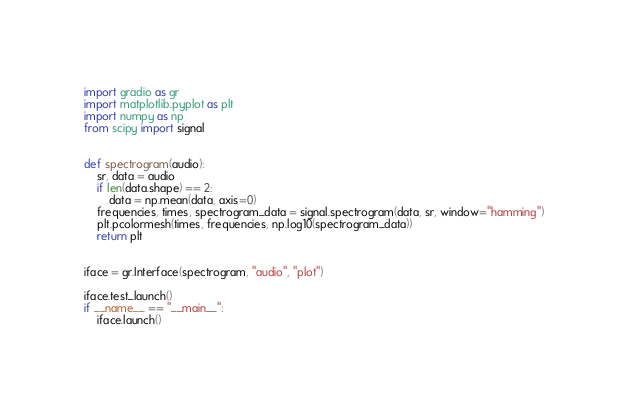Convert code to text. <code><loc_0><loc_0><loc_500><loc_500><_Python_>import gradio as gr
import matplotlib.pyplot as plt
import numpy as np
from scipy import signal


def spectrogram(audio):
    sr, data = audio
    if len(data.shape) == 2:
        data = np.mean(data, axis=0)
    frequencies, times, spectrogram_data = signal.spectrogram(data, sr, window="hamming")
    plt.pcolormesh(times, frequencies, np.log10(spectrogram_data))
    return plt


iface = gr.Interface(spectrogram, "audio", "plot")

iface.test_launch()
if __name__ == "__main__":
    iface.launch()
</code> 